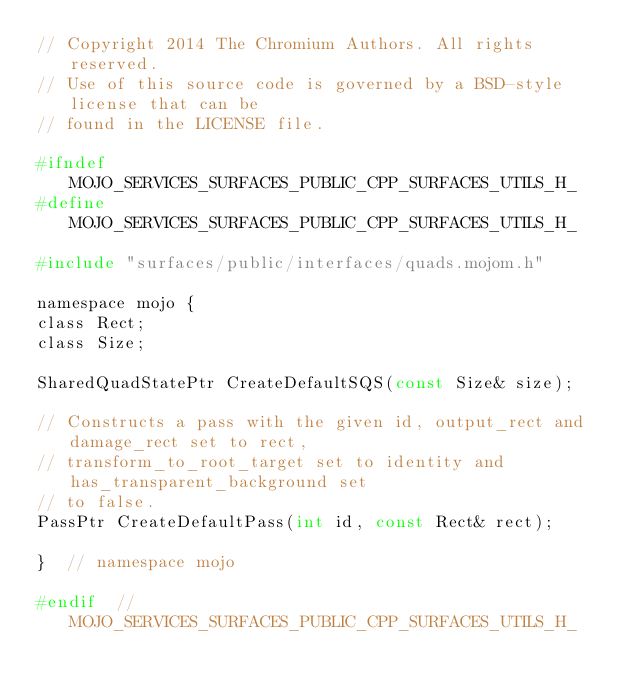Convert code to text. <code><loc_0><loc_0><loc_500><loc_500><_C_>// Copyright 2014 The Chromium Authors. All rights reserved.
// Use of this source code is governed by a BSD-style license that can be
// found in the LICENSE file.

#ifndef MOJO_SERVICES_SURFACES_PUBLIC_CPP_SURFACES_UTILS_H_
#define MOJO_SERVICES_SURFACES_PUBLIC_CPP_SURFACES_UTILS_H_

#include "surfaces/public/interfaces/quads.mojom.h"

namespace mojo {
class Rect;
class Size;

SharedQuadStatePtr CreateDefaultSQS(const Size& size);

// Constructs a pass with the given id, output_rect and damage_rect set to rect,
// transform_to_root_target set to identity and has_transparent_background set
// to false.
PassPtr CreateDefaultPass(int id, const Rect& rect);

}  // namespace mojo

#endif  // MOJO_SERVICES_SURFACES_PUBLIC_CPP_SURFACES_UTILS_H_
</code> 